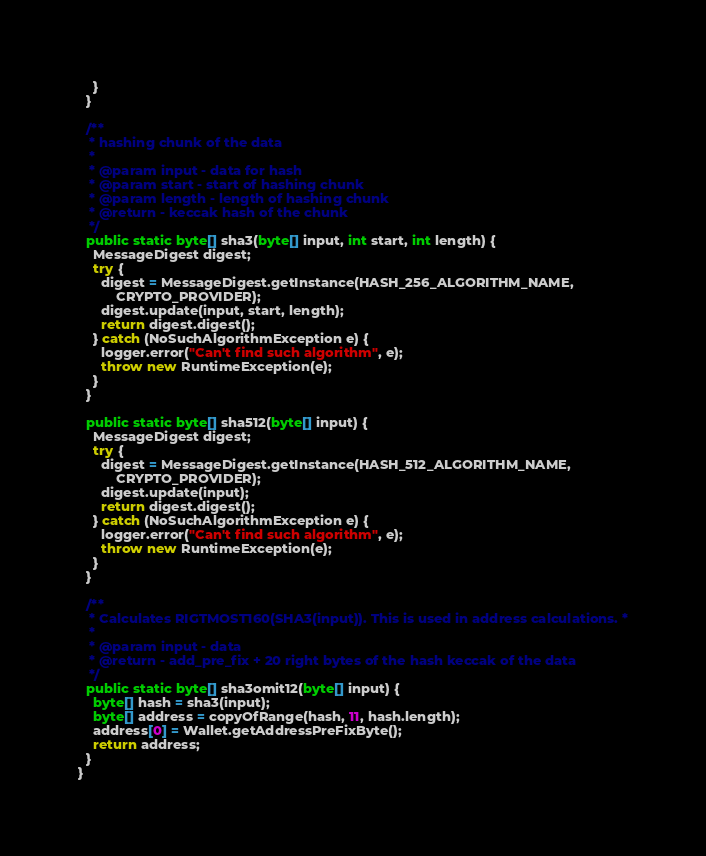<code> <loc_0><loc_0><loc_500><loc_500><_Java_>    }
  }

  /**
   * hashing chunk of the data
   *
   * @param input - data for hash
   * @param start - start of hashing chunk
   * @param length - length of hashing chunk
   * @return - keccak hash of the chunk
   */
  public static byte[] sha3(byte[] input, int start, int length) {
    MessageDigest digest;
    try {
      digest = MessageDigest.getInstance(HASH_256_ALGORITHM_NAME,
          CRYPTO_PROVIDER);
      digest.update(input, start, length);
      return digest.digest();
    } catch (NoSuchAlgorithmException e) {
      logger.error("Can't find such algorithm", e);
      throw new RuntimeException(e);
    }
  }

  public static byte[] sha512(byte[] input) {
    MessageDigest digest;
    try {
      digest = MessageDigest.getInstance(HASH_512_ALGORITHM_NAME,
          CRYPTO_PROVIDER);
      digest.update(input);
      return digest.digest();
    } catch (NoSuchAlgorithmException e) {
      logger.error("Can't find such algorithm", e);
      throw new RuntimeException(e);
    }
  }

  /**
   * Calculates RIGTMOST160(SHA3(input)). This is used in address calculations. *
   *
   * @param input - data
   * @return - add_pre_fix + 20 right bytes of the hash keccak of the data
   */
  public static byte[] sha3omit12(byte[] input) {
    byte[] hash = sha3(input);
    byte[] address = copyOfRange(hash, 11, hash.length);
    address[0] = Wallet.getAddressPreFixByte();
    return address;
  }
}
</code> 